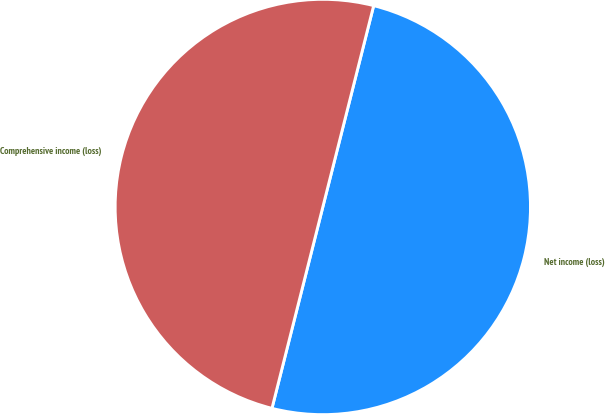<chart> <loc_0><loc_0><loc_500><loc_500><pie_chart><fcel>Net income (loss)<fcel>Comprehensive income (loss)<nl><fcel>50.0%<fcel>50.0%<nl></chart> 